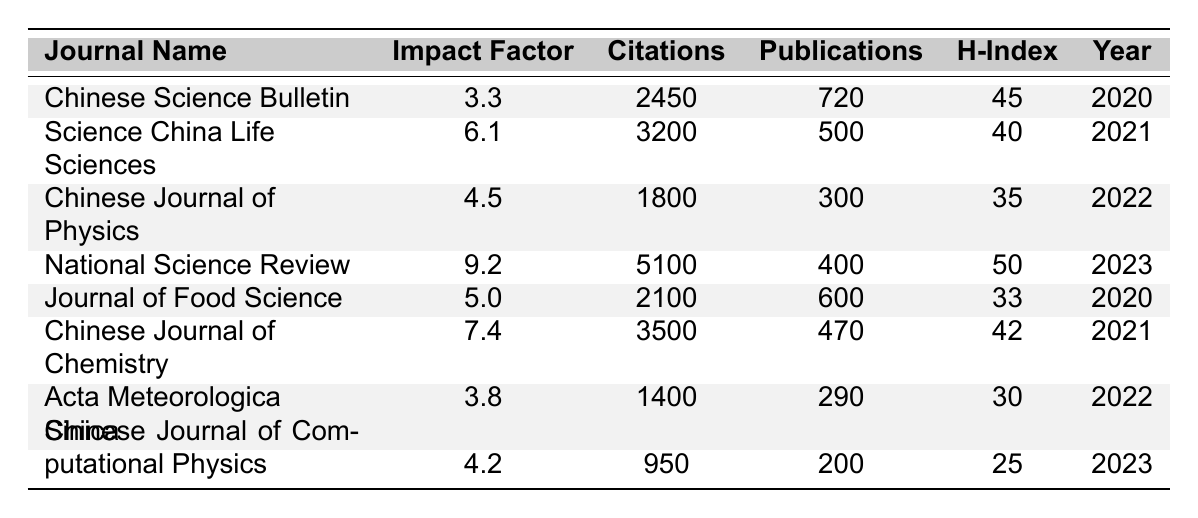What is the Impact Factor of the National Science Review? The table shows that the Impact Factor for the National Science Review is listed as 9.2.
Answer: 9.2 Which journal had the highest number of citations in 2021? The journal with the highest number of citations in 2021 is the Chinese Journal of Chemistry, which had 3500 citations.
Answer: Chinese Journal of Chemistry How many publications did the Chinese Science Bulletin have? From the table, the Chinese Science Bulletin had a total of 720 publications.
Answer: 720 What is the average Impact Factor of the journals listed for the year 2022? For the year 2022, the journals listed are the Chinese Journal of Physics (4.5), Acta Meteorologica Sinica (3.8). The average Impact Factor is (4.5 + 3.8) / 2 = 4.15.
Answer: 4.15 True or False: The Journal of Food Science has more citations than the Chinese Journal of Physics. The Journal of Food Science has 2100 citations while the Chinese Journal of Physics has 1800 citations. Therefore, it is true that the Journal of Food Science has more citations.
Answer: True Which year had the journal with the most publications and what journal was it? The year 2020 had the Chinese Science Bulletin which had the highest number of publications at 720.
Answer: 2020, Chinese Science Bulletin What was the change in citations from the Chinese Science Bulletin in 2020 to National Science Review in 2023? The Chinese Science Bulletin had 2450 citations in 2020 and the National Science Review had 5100 citations in 2023. The change in citations is 5100 - 2450 = 2650 more citations.
Answer: 2650 Which journal had the lowest H-Index in 2023 and what was it? In 2023, the Chinese Journal of Computational Physics had the lowest H-Index of 25.
Answer: 25 